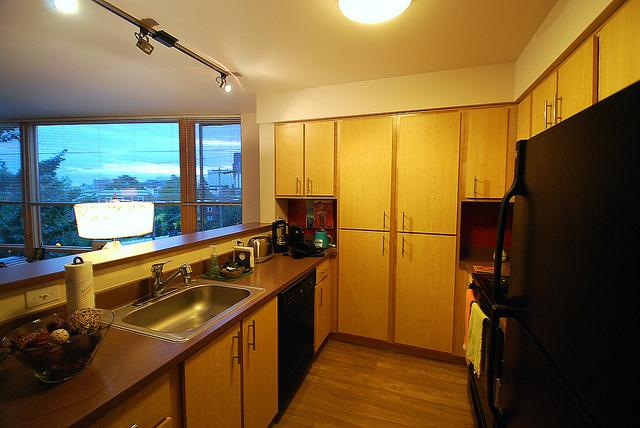What color is the light on top of the sink near the counter?

Choices:
A) orange
B) white
C) yellow
D) red white 